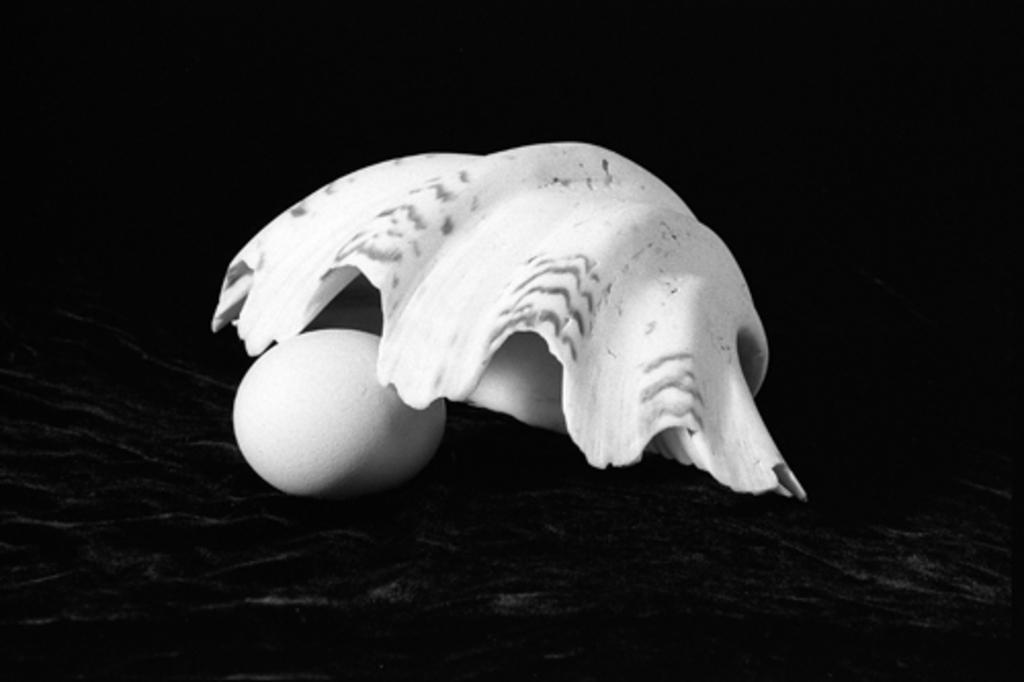Describe this image in one or two sentences. In this picture there is an egg and there is a white color object placed above it. 